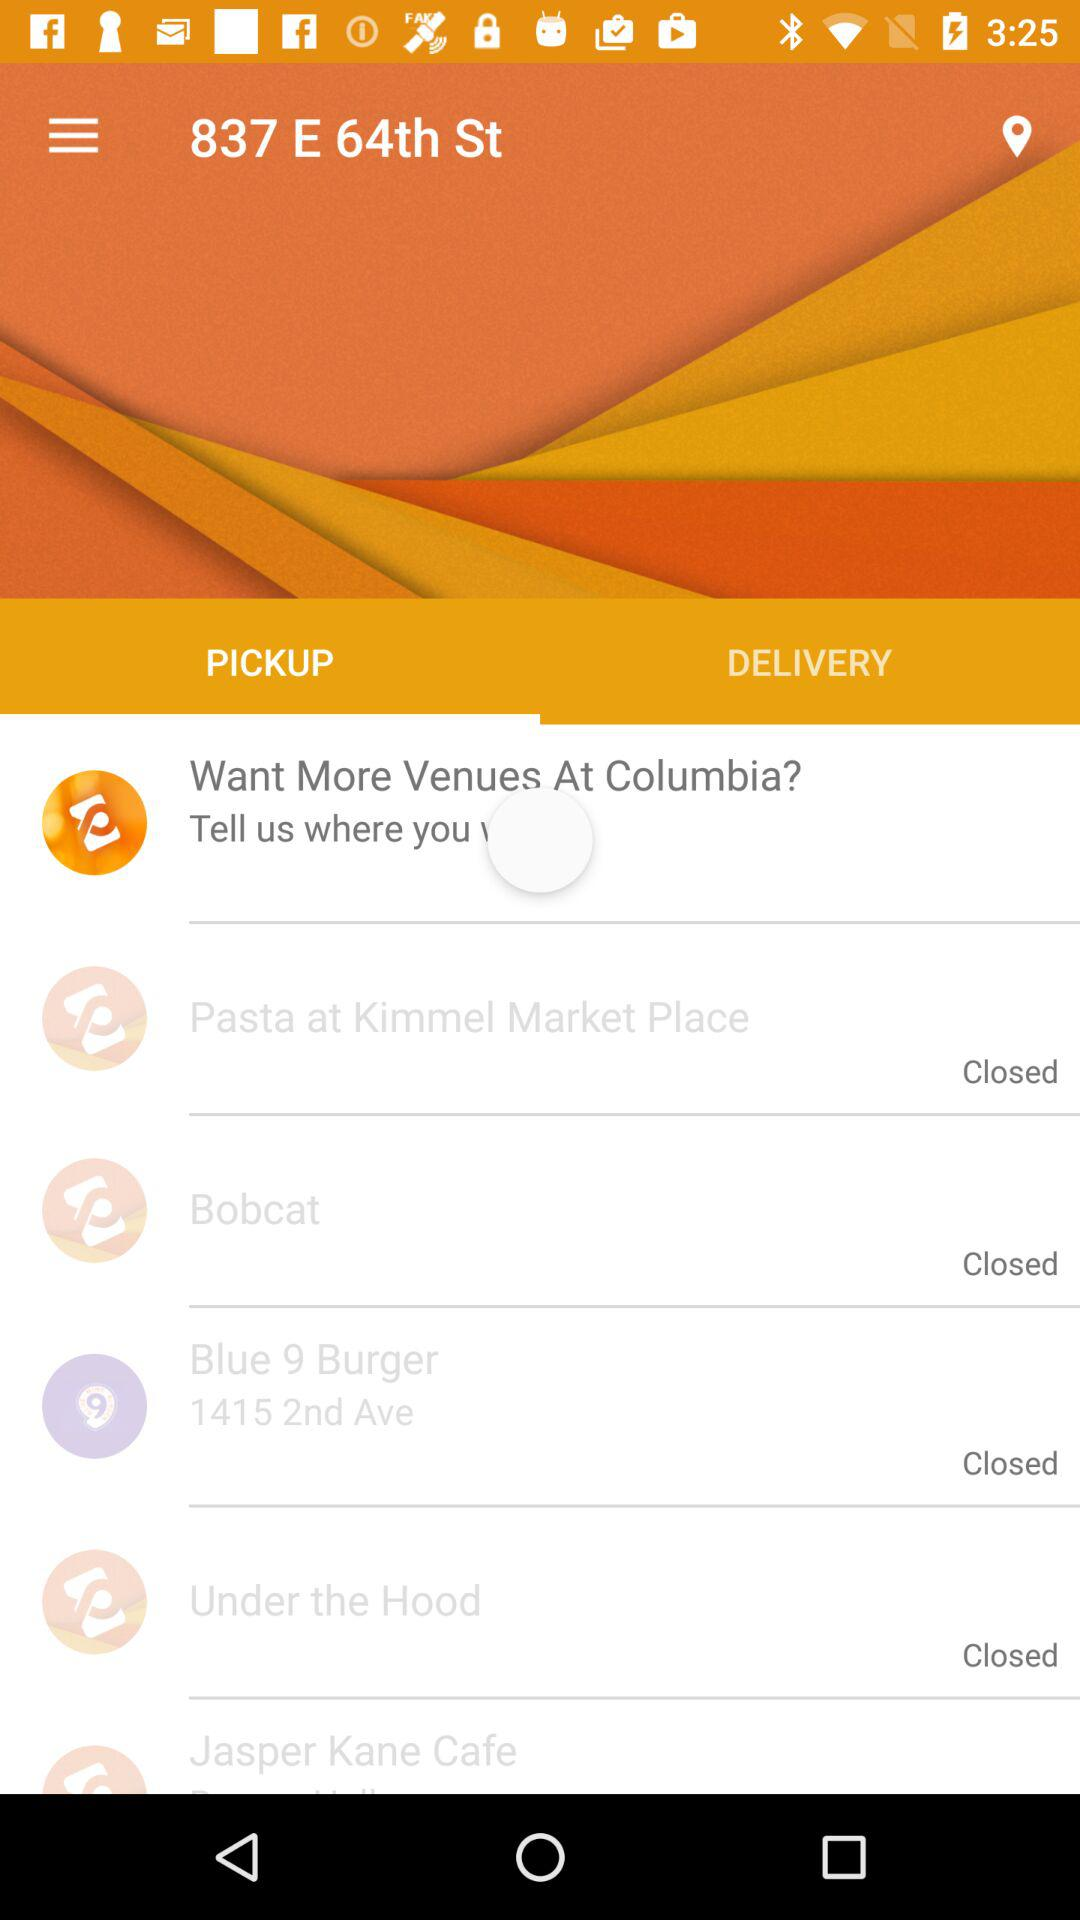What is the location of "Blue 9 Burger"? The location is 1415 2nd Ave. 